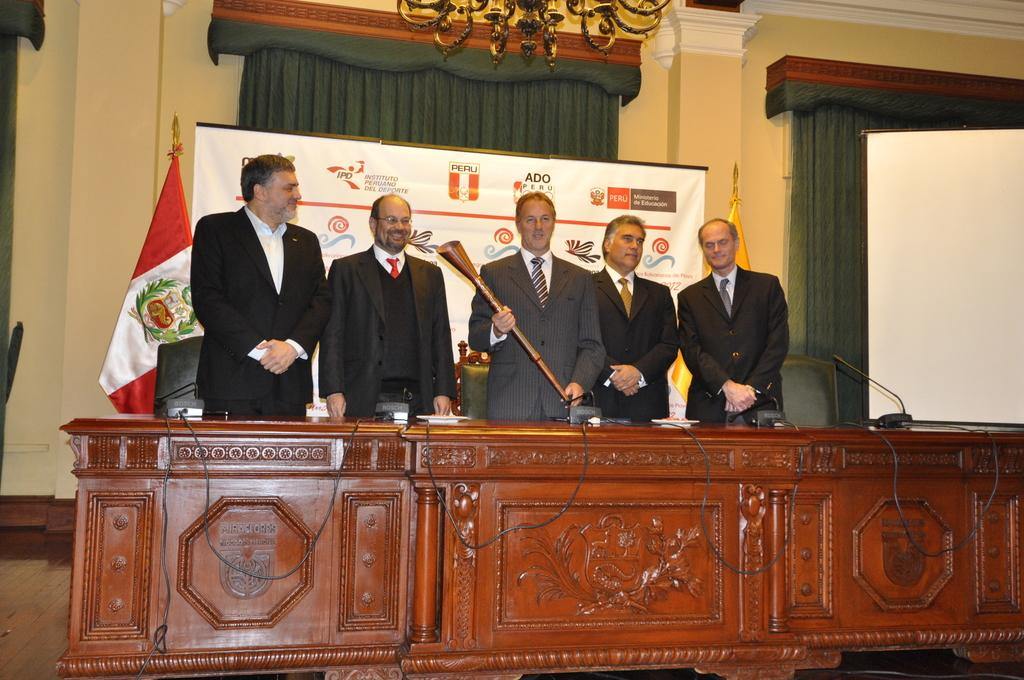What type of device is visible in the image? There is a wireless device in the image. What piece of furniture is present in the image? There is a table in the image. What objects are used for amplifying sound in the image? There are microphones in the image. What items are used to represent a country or organization in the image? There are flags in the image. What is hung on the wall in the image? There is a banner in the image. What type of window treatment is present in the image? There are curtains in the image. What type of lighting fixture is present in the image? There is a chandelier in the image. What is used for writing or displaying information in the image? There is a board in the image. What type of seating is present in the image? There are chairs in the image. How many men are present in the image? There are five men in the image. What type of clothing are the men wearing on their upper bodies? The men are wearing blazers. What type of clothing are the men wearing around their necks? The men are wearing ties. What position are the men in within the image? The men are standing. Can you tell me how many ants are crawling on the wireless device in the image? There are no ants present on the wireless device or in the image. Why are the men crying in the image? The men are not crying in the image; they are standing and wearing blazers and ties. 